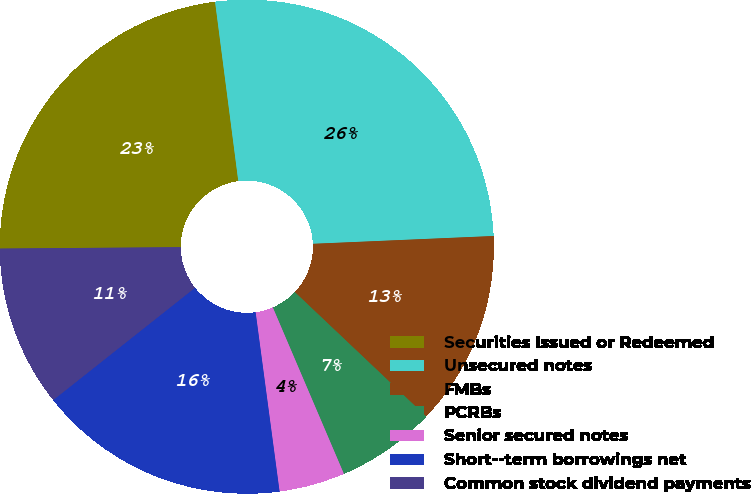<chart> <loc_0><loc_0><loc_500><loc_500><pie_chart><fcel>Securities Issued or Redeemed<fcel>Unsecured notes<fcel>FMBs<fcel>PCRBs<fcel>Senior secured notes<fcel>Short-­term borrowings net<fcel>Common stock dividend payments<nl><fcel>23.07%<fcel>26.36%<fcel>12.75%<fcel>6.51%<fcel>4.31%<fcel>16.45%<fcel>10.54%<nl></chart> 